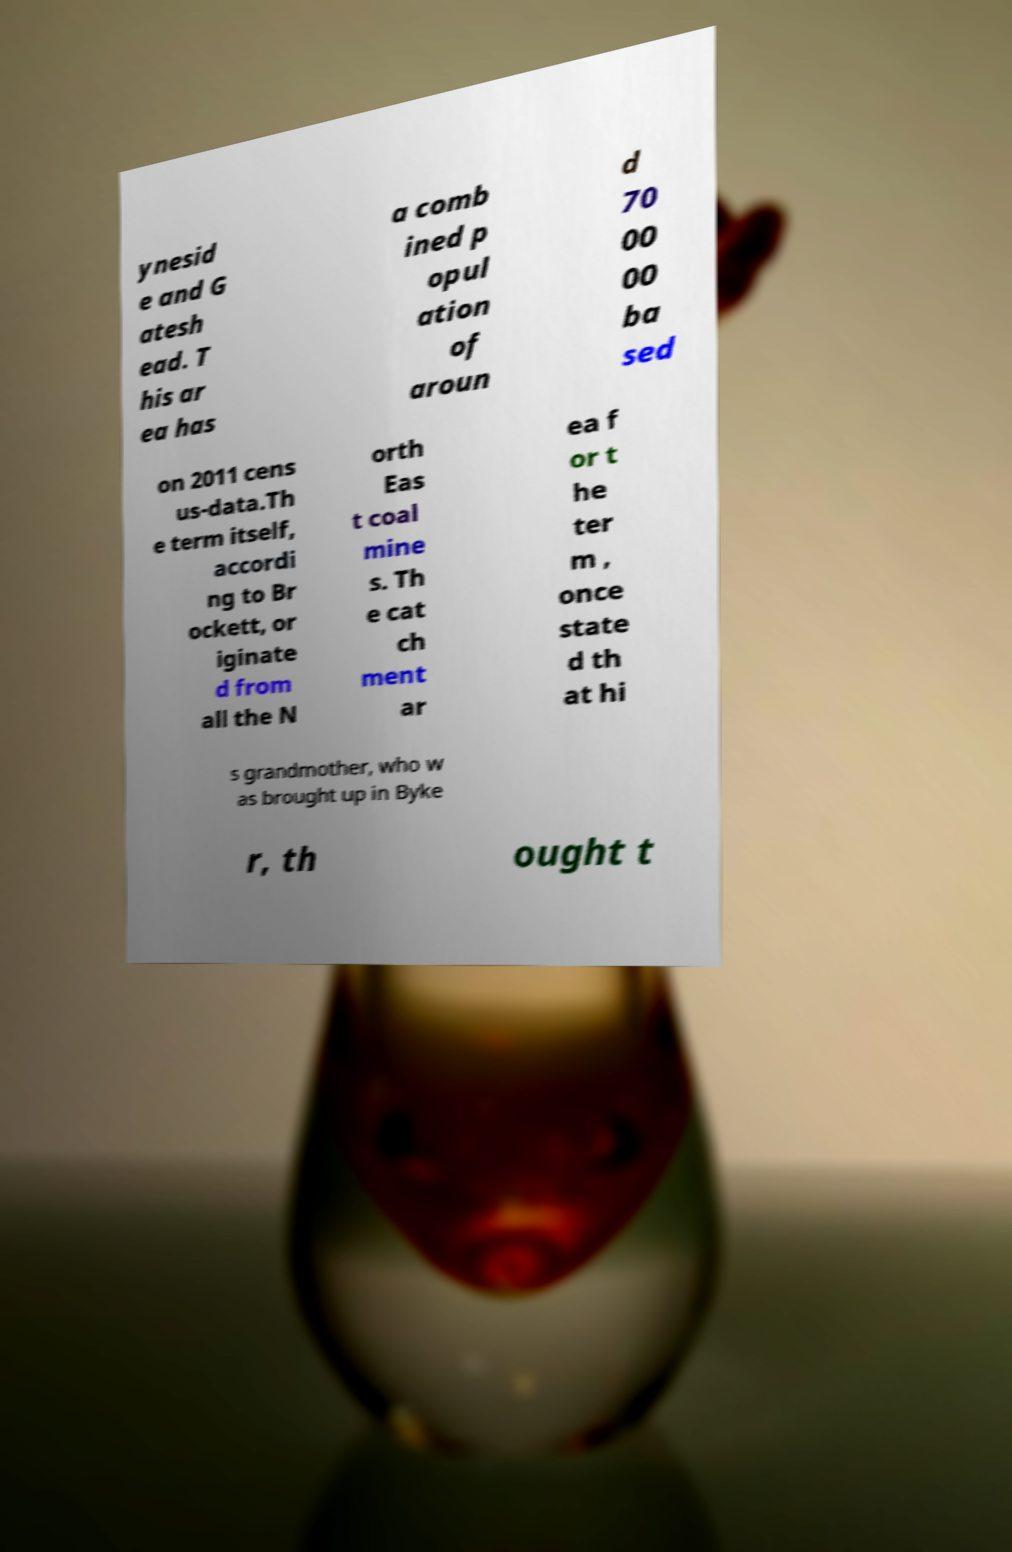There's text embedded in this image that I need extracted. Can you transcribe it verbatim? ynesid e and G atesh ead. T his ar ea has a comb ined p opul ation of aroun d 70 00 00 ba sed on 2011 cens us-data.Th e term itself, accordi ng to Br ockett, or iginate d from all the N orth Eas t coal mine s. Th e cat ch ment ar ea f or t he ter m , once state d th at hi s grandmother, who w as brought up in Byke r, th ought t 